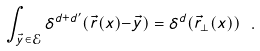<formula> <loc_0><loc_0><loc_500><loc_500>\int _ { \vec { y } \in \mathcal { E } } \delta ^ { d + d ^ { \prime } } ( \vec { r } ( x ) { - } \vec { y } ) = \delta ^ { d } ( \vec { r } _ { \perp } ( x ) ) \ .</formula> 